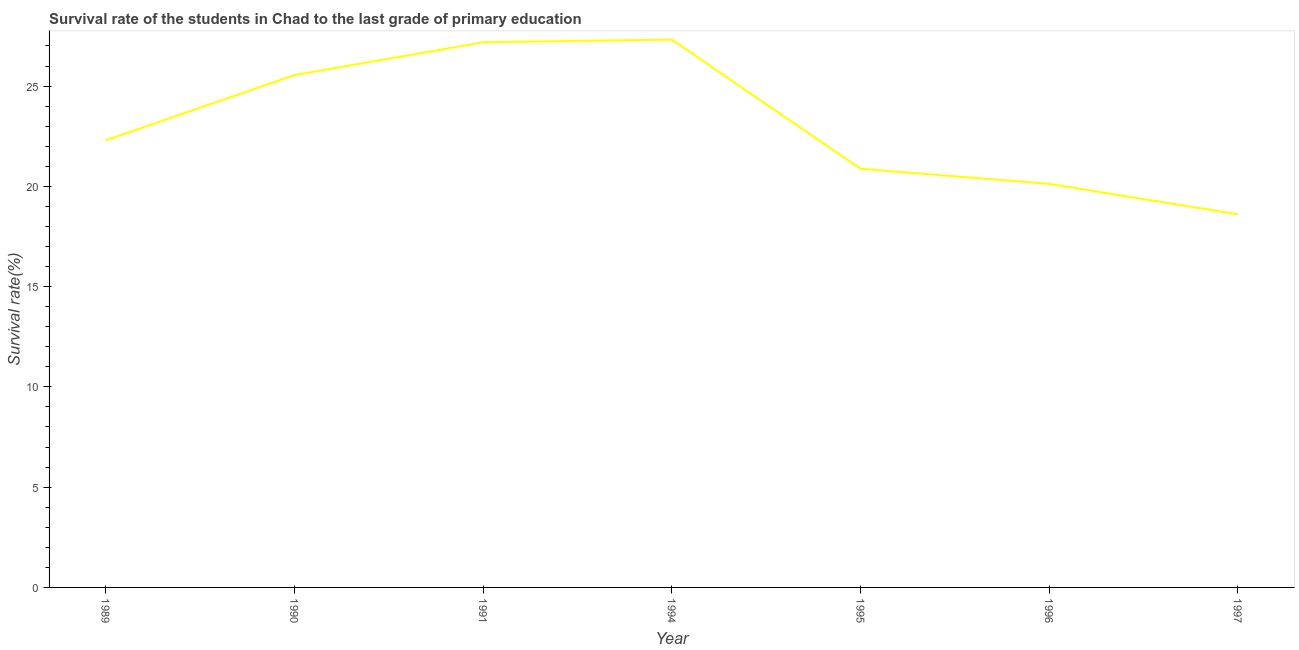What is the survival rate in primary education in 1990?
Ensure brevity in your answer.  25.55. Across all years, what is the maximum survival rate in primary education?
Give a very brief answer. 27.32. Across all years, what is the minimum survival rate in primary education?
Offer a terse response. 18.61. What is the sum of the survival rate in primary education?
Offer a very short reply. 161.95. What is the difference between the survival rate in primary education in 1994 and 1997?
Offer a terse response. 8.71. What is the average survival rate in primary education per year?
Keep it short and to the point. 23.14. What is the median survival rate in primary education?
Make the answer very short. 22.3. What is the ratio of the survival rate in primary education in 1989 to that in 1997?
Offer a terse response. 1.2. Is the survival rate in primary education in 1989 less than that in 1994?
Your response must be concise. Yes. Is the difference between the survival rate in primary education in 1990 and 1994 greater than the difference between any two years?
Your answer should be compact. No. What is the difference between the highest and the second highest survival rate in primary education?
Provide a short and direct response. 0.14. What is the difference between the highest and the lowest survival rate in primary education?
Your response must be concise. 8.71. In how many years, is the survival rate in primary education greater than the average survival rate in primary education taken over all years?
Make the answer very short. 3. What is the difference between two consecutive major ticks on the Y-axis?
Your answer should be very brief. 5. Are the values on the major ticks of Y-axis written in scientific E-notation?
Provide a succinct answer. No. Does the graph contain any zero values?
Keep it short and to the point. No. What is the title of the graph?
Offer a terse response. Survival rate of the students in Chad to the last grade of primary education. What is the label or title of the X-axis?
Your answer should be very brief. Year. What is the label or title of the Y-axis?
Offer a very short reply. Survival rate(%). What is the Survival rate(%) of 1989?
Give a very brief answer. 22.3. What is the Survival rate(%) of 1990?
Offer a terse response. 25.55. What is the Survival rate(%) in 1991?
Give a very brief answer. 27.18. What is the Survival rate(%) in 1994?
Provide a short and direct response. 27.32. What is the Survival rate(%) in 1995?
Provide a short and direct response. 20.88. What is the Survival rate(%) of 1996?
Your answer should be very brief. 20.12. What is the Survival rate(%) of 1997?
Make the answer very short. 18.61. What is the difference between the Survival rate(%) in 1989 and 1990?
Keep it short and to the point. -3.25. What is the difference between the Survival rate(%) in 1989 and 1991?
Your response must be concise. -4.89. What is the difference between the Survival rate(%) in 1989 and 1994?
Provide a short and direct response. -5.02. What is the difference between the Survival rate(%) in 1989 and 1995?
Offer a very short reply. 1.42. What is the difference between the Survival rate(%) in 1989 and 1996?
Provide a succinct answer. 2.17. What is the difference between the Survival rate(%) in 1989 and 1997?
Your answer should be very brief. 3.69. What is the difference between the Survival rate(%) in 1990 and 1991?
Your answer should be very brief. -1.64. What is the difference between the Survival rate(%) in 1990 and 1994?
Give a very brief answer. -1.77. What is the difference between the Survival rate(%) in 1990 and 1995?
Your answer should be compact. 4.67. What is the difference between the Survival rate(%) in 1990 and 1996?
Make the answer very short. 5.42. What is the difference between the Survival rate(%) in 1990 and 1997?
Provide a short and direct response. 6.94. What is the difference between the Survival rate(%) in 1991 and 1994?
Your answer should be very brief. -0.14. What is the difference between the Survival rate(%) in 1991 and 1995?
Provide a short and direct response. 6.31. What is the difference between the Survival rate(%) in 1991 and 1996?
Give a very brief answer. 7.06. What is the difference between the Survival rate(%) in 1991 and 1997?
Offer a very short reply. 8.58. What is the difference between the Survival rate(%) in 1994 and 1995?
Provide a short and direct response. 6.44. What is the difference between the Survival rate(%) in 1994 and 1996?
Your answer should be compact. 7.2. What is the difference between the Survival rate(%) in 1994 and 1997?
Offer a very short reply. 8.71. What is the difference between the Survival rate(%) in 1995 and 1996?
Give a very brief answer. 0.75. What is the difference between the Survival rate(%) in 1995 and 1997?
Your response must be concise. 2.27. What is the difference between the Survival rate(%) in 1996 and 1997?
Offer a very short reply. 1.52. What is the ratio of the Survival rate(%) in 1989 to that in 1990?
Ensure brevity in your answer.  0.87. What is the ratio of the Survival rate(%) in 1989 to that in 1991?
Make the answer very short. 0.82. What is the ratio of the Survival rate(%) in 1989 to that in 1994?
Provide a succinct answer. 0.82. What is the ratio of the Survival rate(%) in 1989 to that in 1995?
Your response must be concise. 1.07. What is the ratio of the Survival rate(%) in 1989 to that in 1996?
Your answer should be compact. 1.11. What is the ratio of the Survival rate(%) in 1989 to that in 1997?
Give a very brief answer. 1.2. What is the ratio of the Survival rate(%) in 1990 to that in 1991?
Offer a terse response. 0.94. What is the ratio of the Survival rate(%) in 1990 to that in 1994?
Keep it short and to the point. 0.94. What is the ratio of the Survival rate(%) in 1990 to that in 1995?
Make the answer very short. 1.22. What is the ratio of the Survival rate(%) in 1990 to that in 1996?
Keep it short and to the point. 1.27. What is the ratio of the Survival rate(%) in 1990 to that in 1997?
Your answer should be very brief. 1.37. What is the ratio of the Survival rate(%) in 1991 to that in 1995?
Offer a very short reply. 1.3. What is the ratio of the Survival rate(%) in 1991 to that in 1996?
Your response must be concise. 1.35. What is the ratio of the Survival rate(%) in 1991 to that in 1997?
Keep it short and to the point. 1.46. What is the ratio of the Survival rate(%) in 1994 to that in 1995?
Make the answer very short. 1.31. What is the ratio of the Survival rate(%) in 1994 to that in 1996?
Provide a short and direct response. 1.36. What is the ratio of the Survival rate(%) in 1994 to that in 1997?
Your answer should be compact. 1.47. What is the ratio of the Survival rate(%) in 1995 to that in 1997?
Give a very brief answer. 1.12. What is the ratio of the Survival rate(%) in 1996 to that in 1997?
Your answer should be compact. 1.08. 